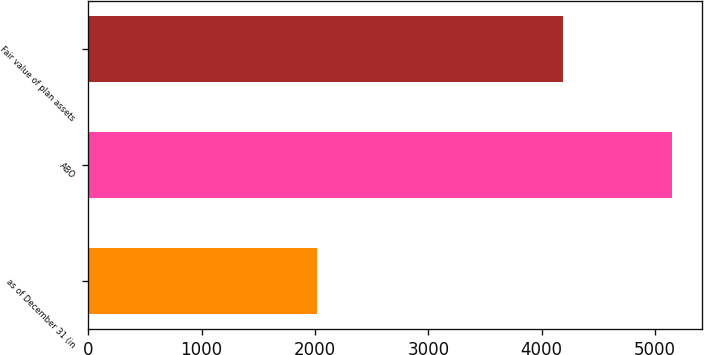Convert chart to OTSL. <chart><loc_0><loc_0><loc_500><loc_500><bar_chart><fcel>as of December 31 (in<fcel>ABO<fcel>Fair value of plan assets<nl><fcel>2016<fcel>5153<fcel>4190<nl></chart> 